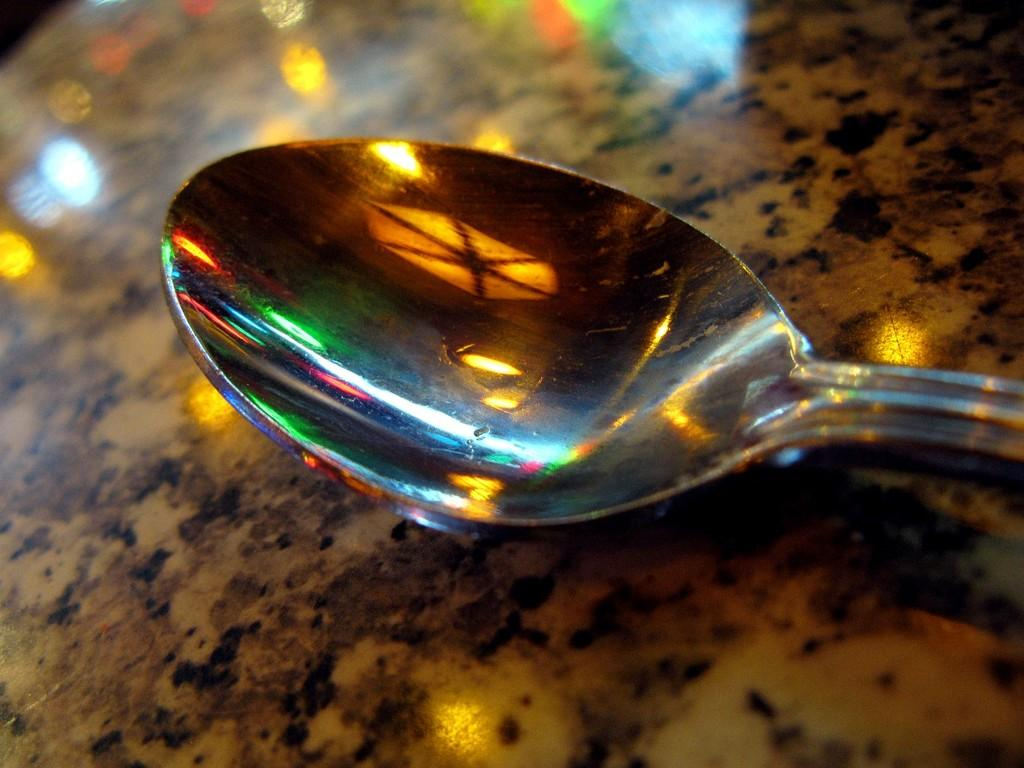What object is visible in the image that is commonly used for eating? There is a spoon in the image. What can be seen reflecting on a platform in the image? There is a reflection of lights on a platform in the image. What type of band is performing on the platform in the image? There is no band present in the image; it only shows a spoon and a reflection of lights on a platform. What color is the vest worn by the donkey in the image? There is no donkey or vest present in the image. 